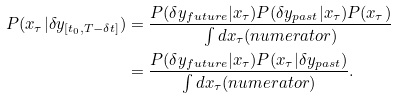<formula> <loc_0><loc_0><loc_500><loc_500>P ( x _ { \tau } | \delta y _ { [ t _ { 0 } , T - \delta t ] } ) & = \frac { P ( \delta y _ { f u t u r e } | x _ { \tau } ) P ( \delta y _ { p a s t } | x _ { \tau } ) P ( x _ { \tau } ) } { \int d x _ { \tau } ( n u m e r a t o r ) } \\ & = \frac { P ( \delta y _ { f u t u r e } | x _ { \tau } ) P ( x _ { \tau } | \delta y _ { p a s t } ) } { \int d x _ { \tau } ( n u m e r a t o r ) } .</formula> 